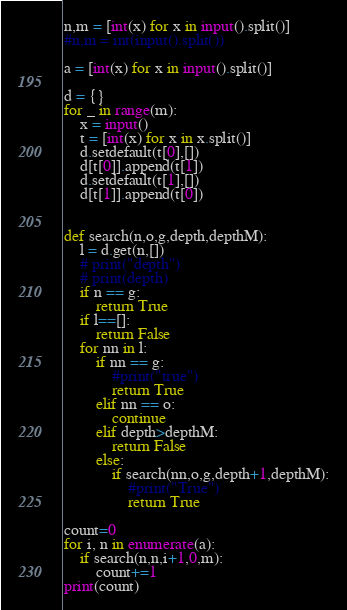Convert code to text. <code><loc_0><loc_0><loc_500><loc_500><_Python_>
n,m = [int(x) for x in input().split()]
#n,m = int(input().split())

a = [int(x) for x in input().split()]

d = {}
for _ in range(m):
    x = input()
    t = [int(x) for x in x.split()]
    d.setdefault(t[0],[])
    d[t[0]].append(t[1])
    d.setdefault(t[1],[])
    d[t[1]].append(t[0])
    

def search(n,o,g,depth,depthM):
    l = d.get(n,[])
    # print("depth")
    # print(depth)
    if n == g:
        return True
    if l==[]:
        return False
    for nn in l:
        if nn == g:
            #print("true")
            return True
        elif nn == o:
            continue
        elif depth>depthM:
            return False
        else:
            if search(nn,o,g,depth+1,depthM):
                #print("True")
                return True

count=0   
for i, n in enumerate(a):
    if search(n,n,i+1,0,m):
        count+=1
print(count)
</code> 